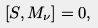Convert formula to latex. <formula><loc_0><loc_0><loc_500><loc_500>[ S , M _ { \nu } ] = 0 ,</formula> 